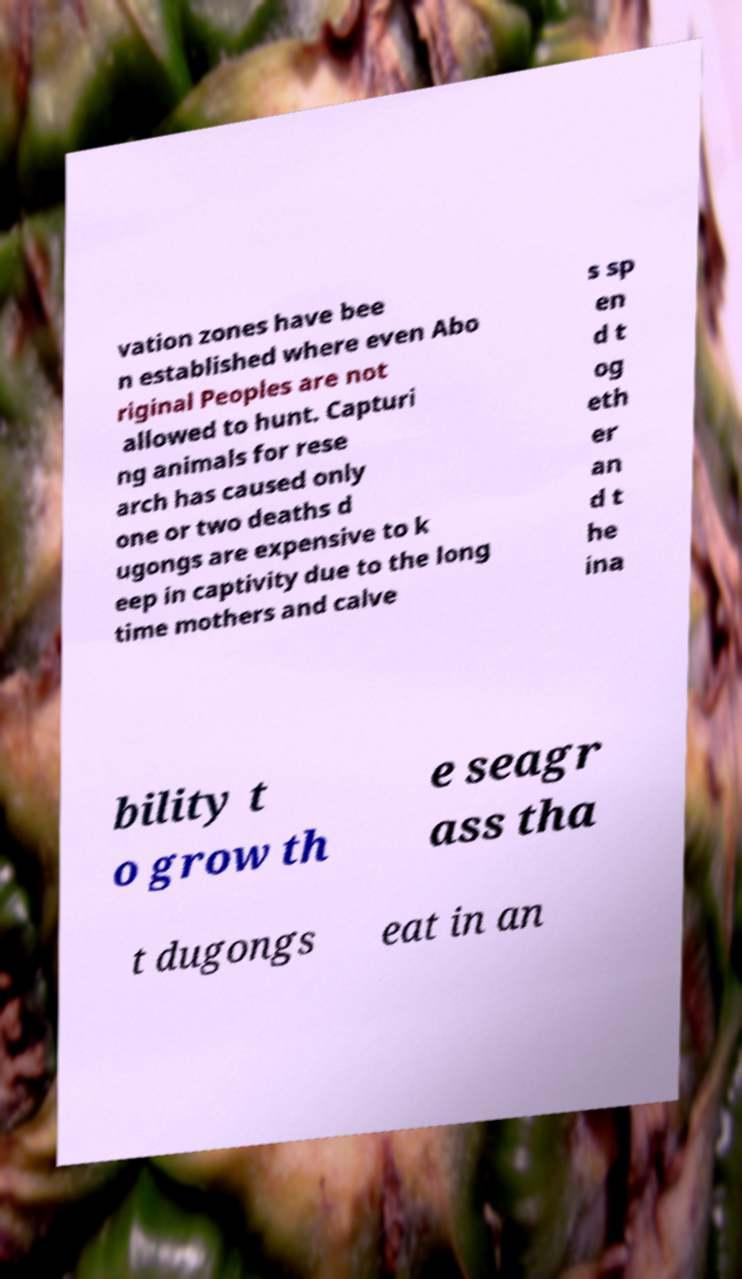Can you read and provide the text displayed in the image?This photo seems to have some interesting text. Can you extract and type it out for me? vation zones have bee n established where even Abo riginal Peoples are not allowed to hunt. Capturi ng animals for rese arch has caused only one or two deaths d ugongs are expensive to k eep in captivity due to the long time mothers and calve s sp en d t og eth er an d t he ina bility t o grow th e seagr ass tha t dugongs eat in an 